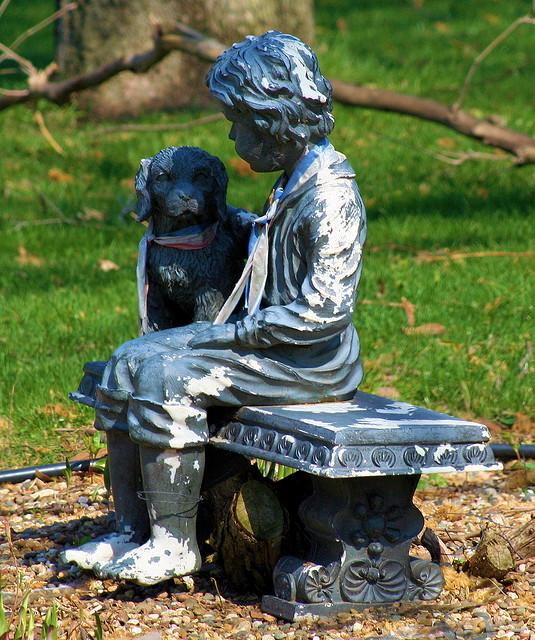Why is this statue partially white? chipped paint 